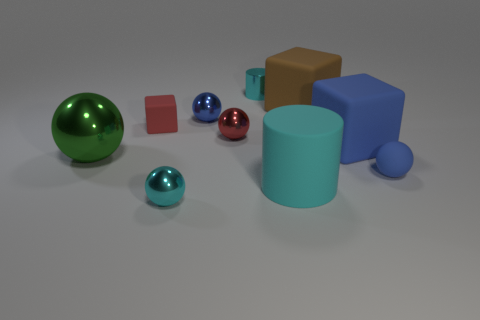Does the red thing on the left side of the cyan ball have the same size as the cyan metallic thing that is in front of the tiny blue matte ball?
Your response must be concise. Yes. How many things are either big rubber things that are behind the tiny matte ball or cyan rubber things?
Give a very brief answer. 3. What is the brown object made of?
Provide a succinct answer. Rubber. Do the brown rubber block and the cyan matte thing have the same size?
Your answer should be compact. Yes. What number of cylinders are either tiny objects or green matte objects?
Keep it short and to the point. 1. The cylinder that is on the left side of the cylinder to the right of the tiny cyan metal cylinder is what color?
Ensure brevity in your answer.  Cyan. Is the number of blue rubber spheres behind the red matte cube less than the number of cylinders that are in front of the tiny blue metal thing?
Give a very brief answer. Yes. There is a blue shiny object; is it the same size as the cyan thing that is behind the small blue matte sphere?
Make the answer very short. Yes. There is a rubber thing that is both behind the big cyan cylinder and in front of the large blue matte object; what is its shape?
Provide a short and direct response. Sphere. There is a brown thing that is the same material as the big cyan thing; what is its size?
Make the answer very short. Large. 